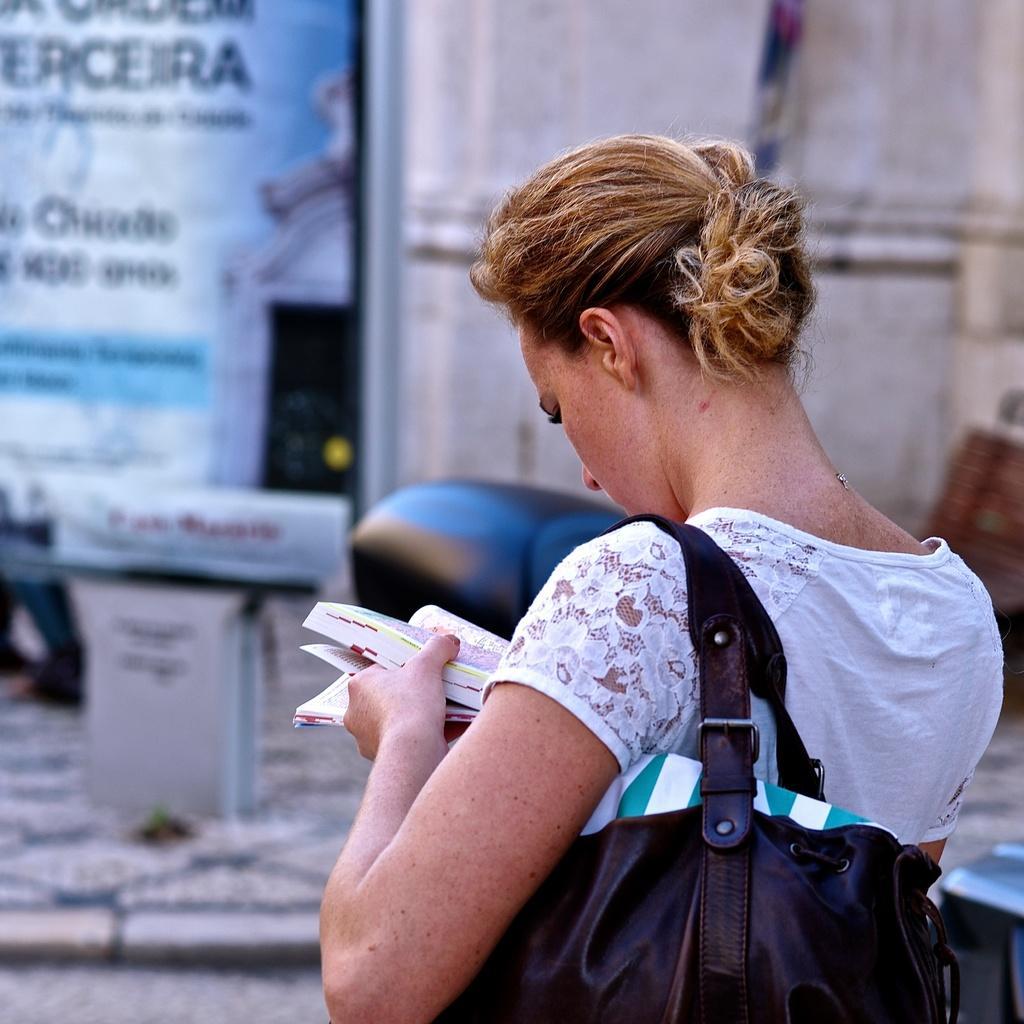In one or two sentences, can you explain what this image depicts? In the middle a woman is holding a hand bag and also book in her hands, She wore a white color t-shirt. 